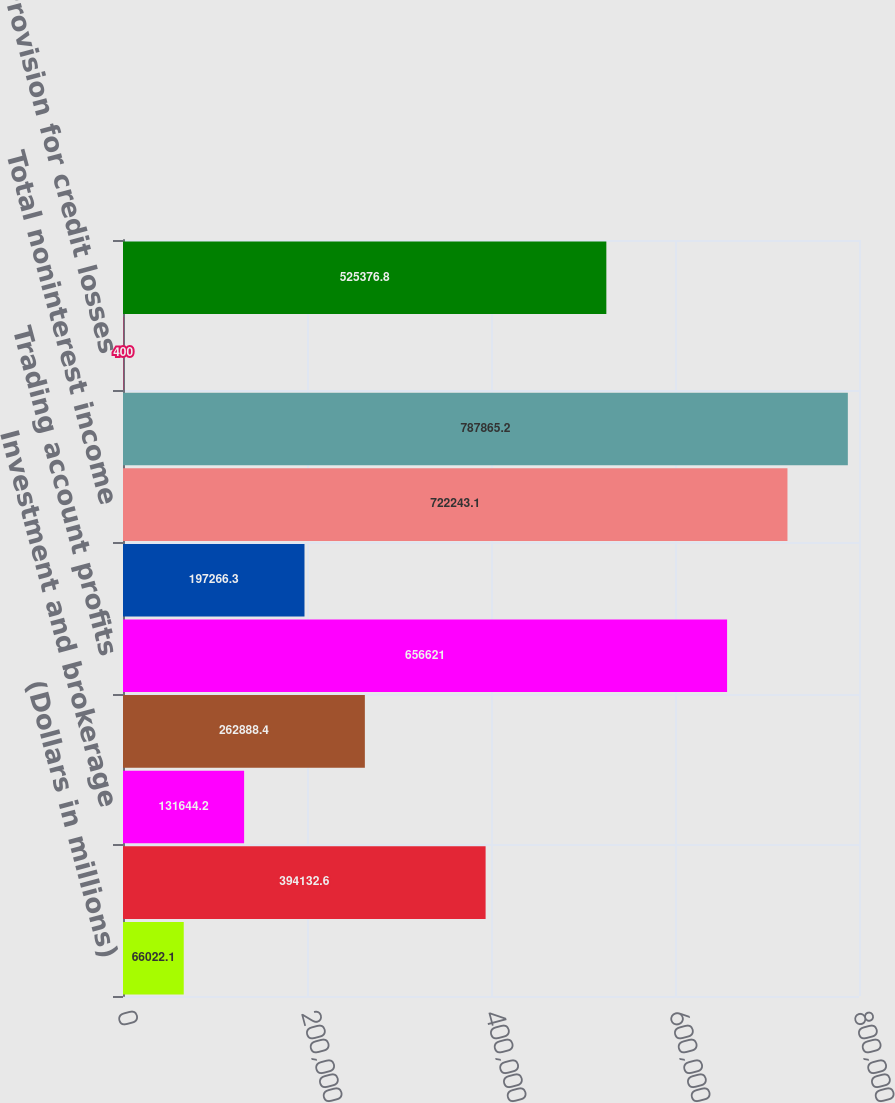Convert chart to OTSL. <chart><loc_0><loc_0><loc_500><loc_500><bar_chart><fcel>(Dollars in millions)<fcel>Net interest income (1)<fcel>Investment and brokerage<fcel>Investment banking income<fcel>Trading account profits<fcel>All other income (loss)<fcel>Total noninterest income<fcel>Total revenue net of interest<fcel>Provision for credit losses<fcel>Noninterest expense<nl><fcel>66022.1<fcel>394133<fcel>131644<fcel>262888<fcel>656621<fcel>197266<fcel>722243<fcel>787865<fcel>400<fcel>525377<nl></chart> 